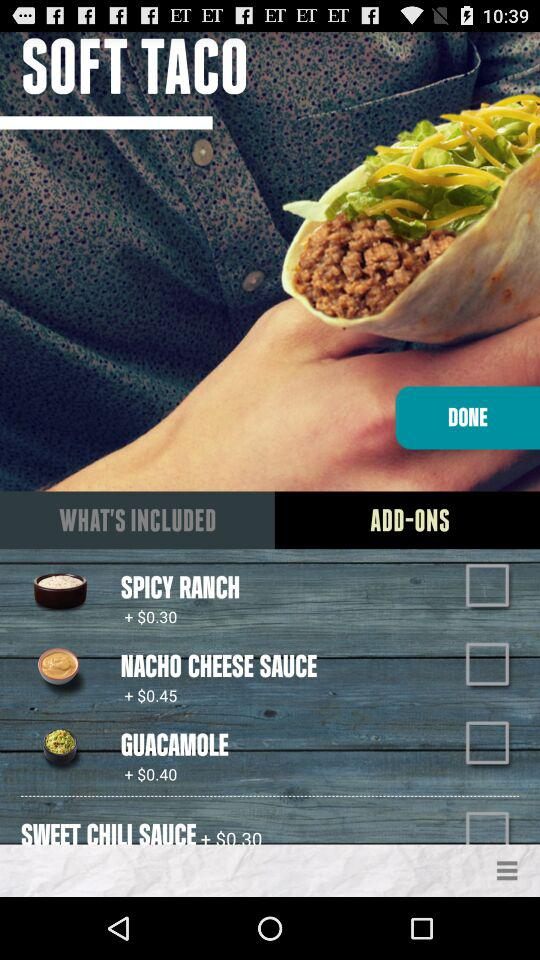How many add-ons are there?
Answer the question using a single word or phrase. 4 